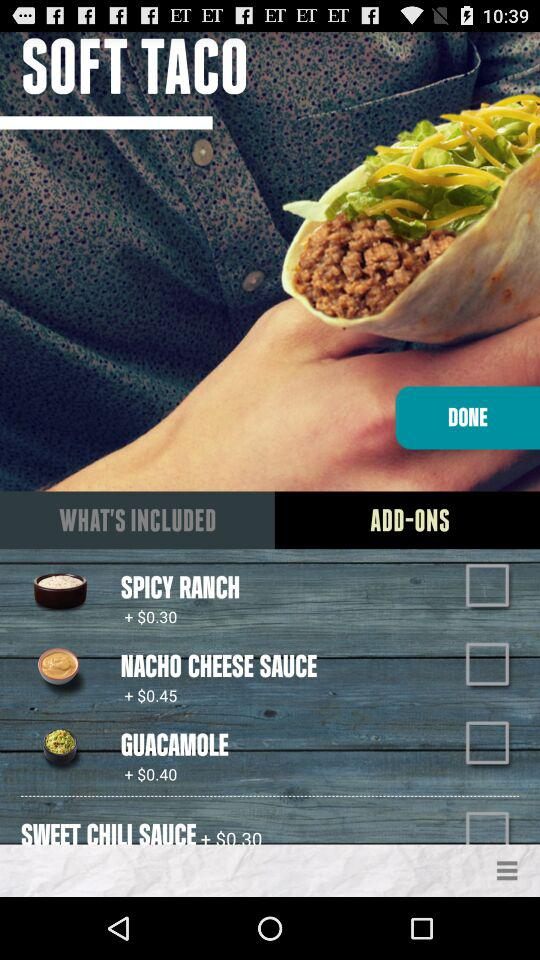How many add-ons are there?
Answer the question using a single word or phrase. 4 